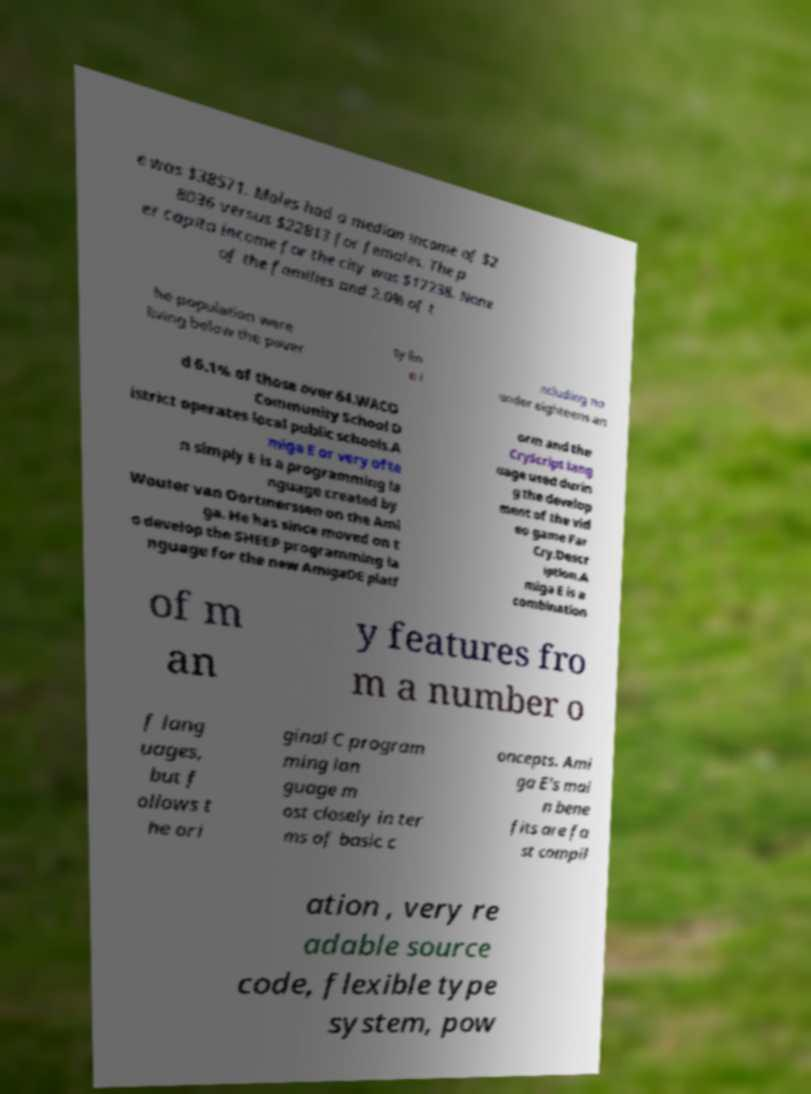What messages or text are displayed in this image? I need them in a readable, typed format. e was $38571. Males had a median income of $2 8036 versus $22813 for females. The p er capita income for the city was $17238. None of the families and 2.0% of t he population were living below the pover ty lin e i ncluding no under eighteens an d 6.1% of those over 64.WACO Community School D istrict operates local public schools.A miga E or very ofte n simply E is a programming la nguage created by Wouter van Oortmerssen on the Ami ga. He has since moved on t o develop the SHEEP programming la nguage for the new AmigaDE platf orm and the CryScript lang uage used durin g the develop ment of the vid eo game Far Cry.Descr iption.A miga E is a combination of m an y features fro m a number o f lang uages, but f ollows t he ori ginal C program ming lan guage m ost closely in ter ms of basic c oncepts. Ami ga E's mai n bene fits are fa st compil ation , very re adable source code, flexible type system, pow 